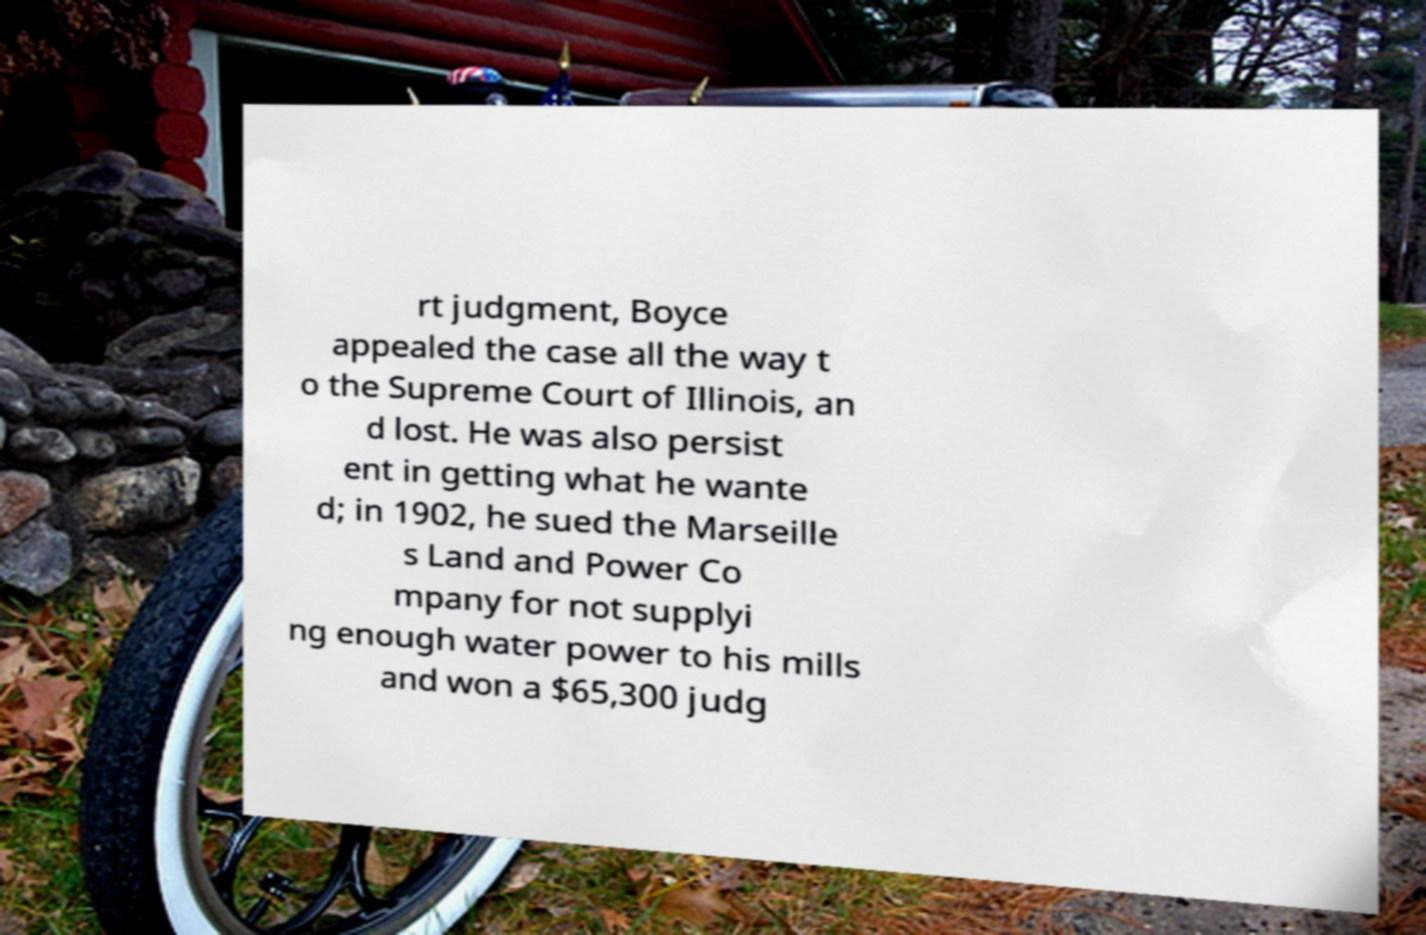Could you extract and type out the text from this image? rt judgment, Boyce appealed the case all the way t o the Supreme Court of Illinois, an d lost. He was also persist ent in getting what he wante d; in 1902, he sued the Marseille s Land and Power Co mpany for not supplyi ng enough water power to his mills and won a $65,300 judg 